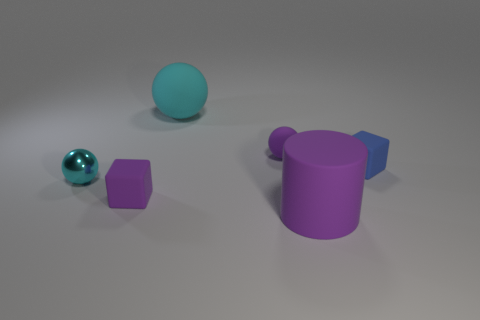There is a blue rubber object that is the same size as the metal object; what is its shape?
Provide a succinct answer. Cube. Are there any metallic things that have the same color as the large ball?
Provide a short and direct response. Yes. There is a large ball; does it have the same color as the tiny metallic sphere on the left side of the rubber cylinder?
Provide a short and direct response. Yes. What is the size of the rubber sphere that is in front of the large rubber thing that is to the left of the purple object that is in front of the purple rubber block?
Offer a very short reply. Small. There is a small cube that is the same color as the matte cylinder; what is it made of?
Ensure brevity in your answer.  Rubber. Is there any other thing that has the same shape as the big purple matte object?
Give a very brief answer. No. There is a cyan sphere behind the small rubber cube that is right of the small purple rubber sphere; what is its size?
Provide a short and direct response. Large. How many large things are either blue cubes or yellow cylinders?
Offer a very short reply. 0. Is the number of tiny purple spheres less than the number of big green spheres?
Keep it short and to the point. No. Is the color of the cylinder the same as the small rubber ball?
Offer a very short reply. Yes. 